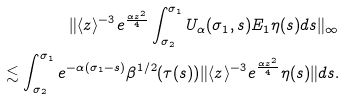Convert formula to latex. <formula><loc_0><loc_0><loc_500><loc_500>\| \langle z \rangle ^ { - 3 } e ^ { \frac { \alpha z ^ { 2 } } { 4 } } \int _ { \sigma _ { 2 } } ^ { \sigma _ { 1 } } U _ { \alpha } ( \sigma _ { 1 } , s ) E _ { 1 } \eta ( s ) d s \| _ { \infty } \\ \lesssim \int _ { \sigma _ { 2 } } ^ { \sigma _ { 1 } } e ^ { - \alpha ( \sigma _ { 1 } - s ) } \beta ^ { 1 / 2 } ( \tau ( s ) ) \| \langle z \rangle ^ { - 3 } e ^ { \frac { \alpha z ^ { 2 } } { 4 } } \eta ( s ) \| d s .</formula> 